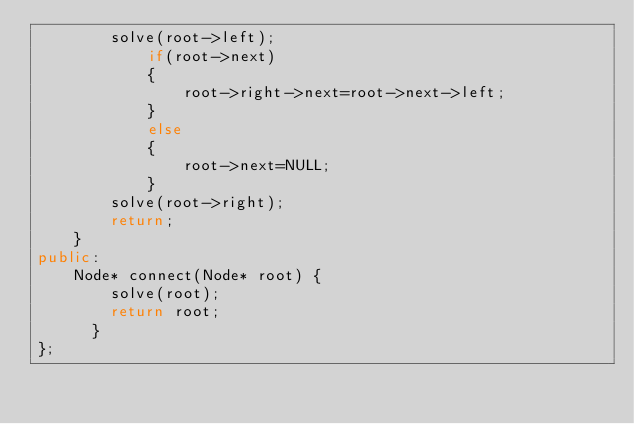<code> <loc_0><loc_0><loc_500><loc_500><_C++_>        solve(root->left);
            if(root->next)
            {
                root->right->next=root->next->left;
            }
            else
            {
                root->next=NULL;
            }
        solve(root->right);
        return;
    }
public:
    Node* connect(Node* root) {
        solve(root);
        return root;
      }
};
</code> 